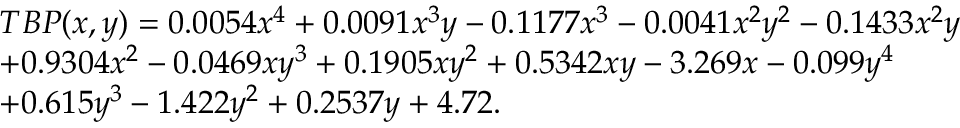Convert formula to latex. <formula><loc_0><loc_0><loc_500><loc_500>\begin{array} { r l } & { T B P ( x , y ) = 0 . 0 0 5 4 x ^ { 4 } + 0 . 0 0 9 1 x ^ { 3 } y - 0 . 1 1 7 7 x ^ { 3 } - 0 . 0 0 4 1 x ^ { 2 } y ^ { 2 } - 0 . 1 4 3 3 x ^ { 2 } y } \\ & { + 0 . 9 3 0 4 x ^ { 2 } - 0 . 0 4 6 9 x y ^ { 3 } + 0 . 1 9 0 5 x y ^ { 2 } + 0 . 5 3 4 2 x y - 3 . 2 6 9 x - 0 . 0 9 9 y ^ { 4 } } \\ & { + 0 . 6 1 5 y ^ { 3 } - 1 . 4 2 2 y ^ { 2 } + 0 . 2 5 3 7 y + 4 . 7 2 . } \end{array}</formula> 